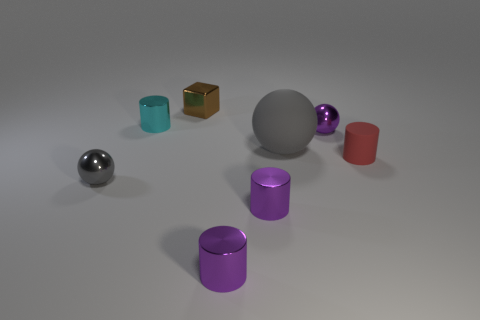Add 1 small objects. How many objects exist? 9 Subtract all balls. How many objects are left? 5 Add 3 big rubber objects. How many big rubber objects exist? 4 Subtract 2 purple cylinders. How many objects are left? 6 Subtract all cyan matte things. Subtract all big matte objects. How many objects are left? 7 Add 8 small gray metallic things. How many small gray metallic things are left? 9 